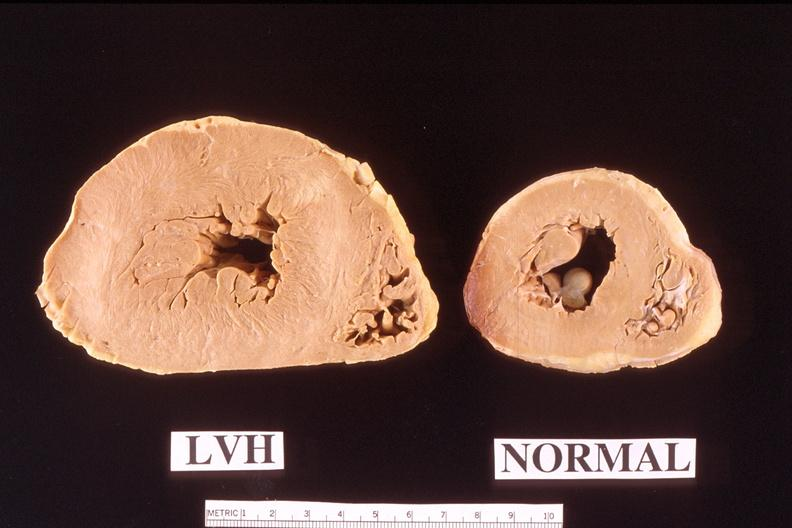what does this image show?
Answer the question using a single word or phrase. Heart 